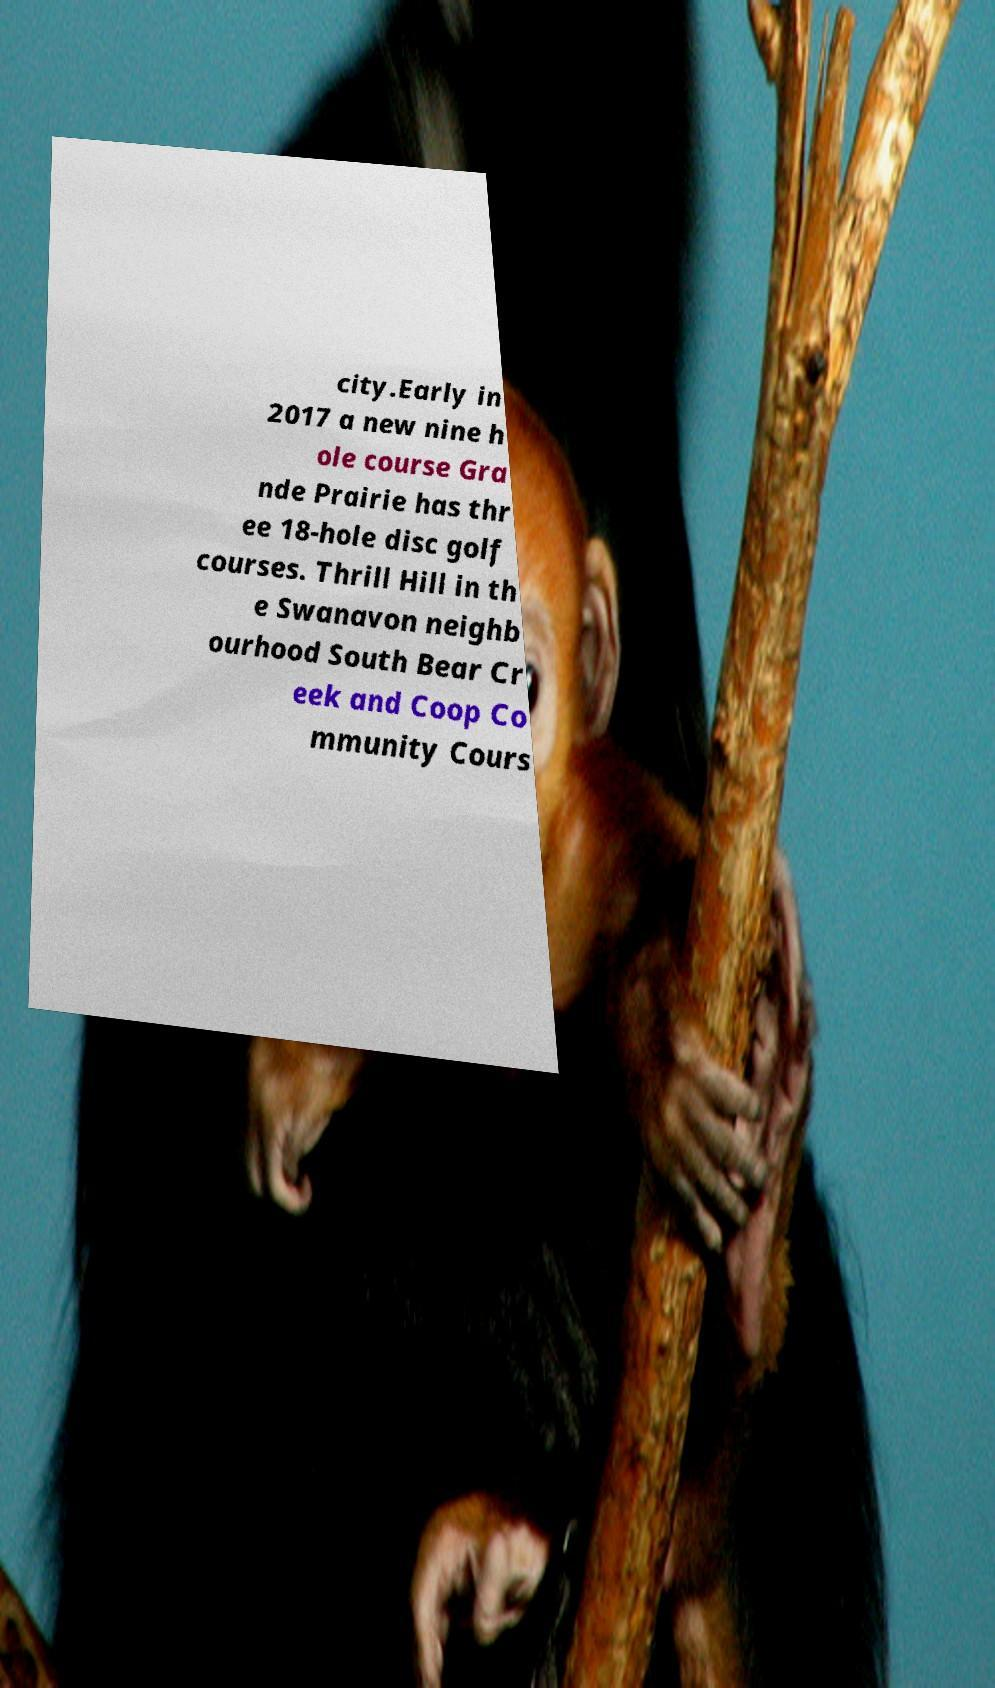Can you read and provide the text displayed in the image?This photo seems to have some interesting text. Can you extract and type it out for me? city.Early in 2017 a new nine h ole course Gra nde Prairie has thr ee 18-hole disc golf courses. Thrill Hill in th e Swanavon neighb ourhood South Bear Cr eek and Coop Co mmunity Cours 